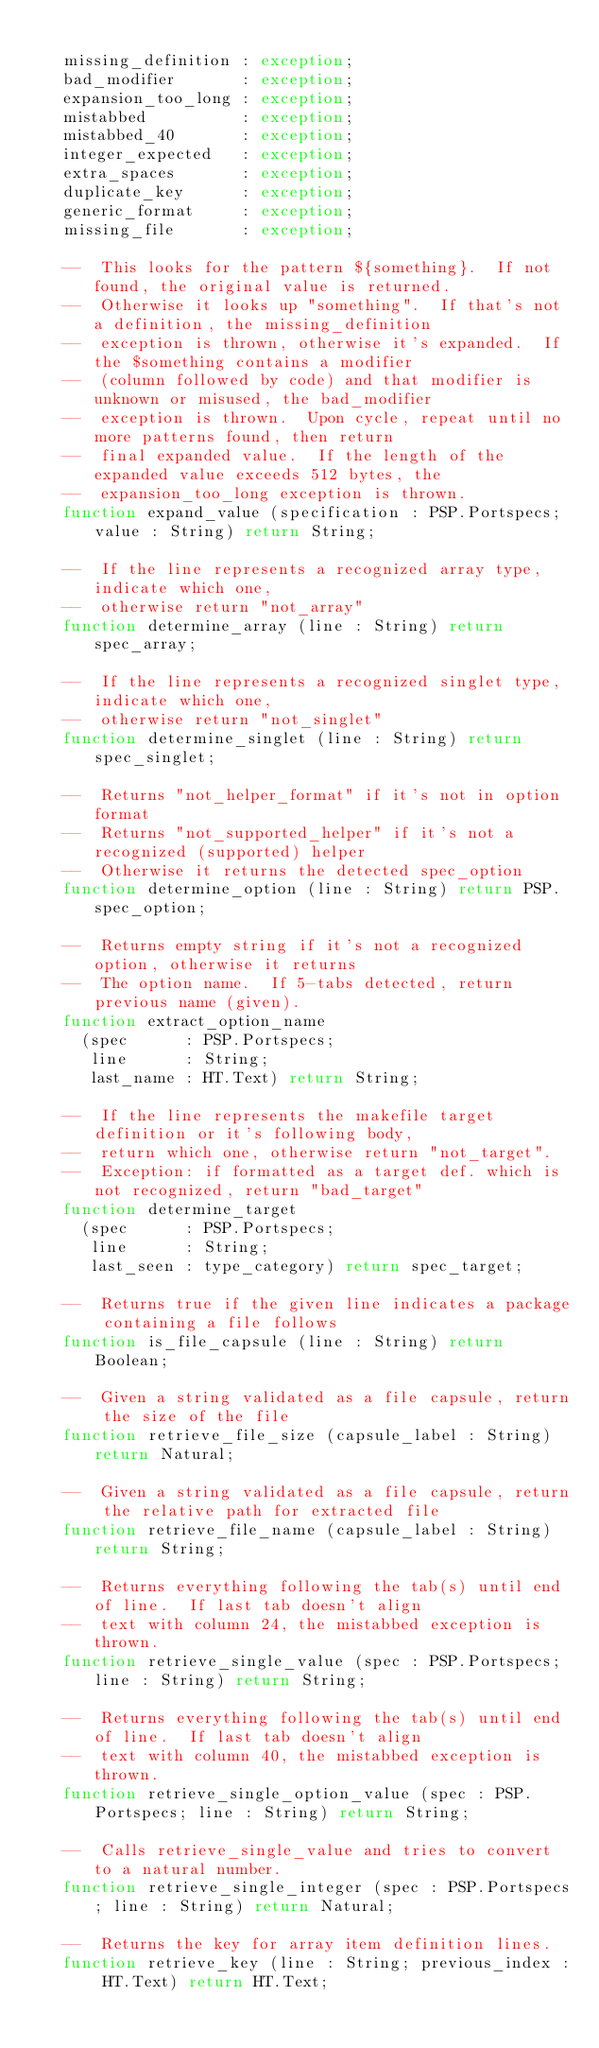Convert code to text. <code><loc_0><loc_0><loc_500><loc_500><_Ada_>
   missing_definition : exception;
   bad_modifier       : exception;
   expansion_too_long : exception;
   mistabbed          : exception;
   mistabbed_40       : exception;
   integer_expected   : exception;
   extra_spaces       : exception;
   duplicate_key      : exception;
   generic_format     : exception;
   missing_file       : exception;

   --  This looks for the pattern ${something}.  If not found, the original value is returned.
   --  Otherwise it looks up "something".  If that's not a definition, the missing_definition
   --  exception is thrown, otherwise it's expanded.  If the $something contains a modifier
   --  (column followed by code) and that modifier is unknown or misused, the bad_modifier
   --  exception is thrown.  Upon cycle, repeat until no more patterns found, then return
   --  final expanded value.  If the length of the expanded value exceeds 512 bytes, the
   --  expansion_too_long exception is thrown.
   function expand_value (specification : PSP.Portspecs; value : String) return String;

   --  If the line represents a recognized array type, indicate which one,
   --  otherwise return "not_array"
   function determine_array (line : String) return spec_array;

   --  If the line represents a recognized singlet type, indicate which one,
   --  otherwise return "not_singlet"
   function determine_singlet (line : String) return spec_singlet;

   --  Returns "not_helper_format" if it's not in option format
   --  Returns "not_supported_helper" if it's not a recognized (supported) helper
   --  Otherwise it returns the detected spec_option
   function determine_option (line : String) return PSP.spec_option;

   --  Returns empty string if it's not a recognized option, otherwise it returns
   --  The option name.  If 5-tabs detected, return previous name (given).
   function extract_option_name
     (spec      : PSP.Portspecs;
      line      : String;
      last_name : HT.Text) return String;

   --  If the line represents the makefile target definition or it's following body,
   --  return which one, otherwise return "not_target".
   --  Exception: if formatted as a target def. which is not recognized, return "bad_target"
   function determine_target
     (spec      : PSP.Portspecs;
      line      : String;
      last_seen : type_category) return spec_target;

   --  Returns true if the given line indicates a package containing a file follows
   function is_file_capsule (line : String) return Boolean;

   --  Given a string validated as a file capsule, return the size of the file
   function retrieve_file_size (capsule_label : String) return Natural;

   --  Given a string validated as a file capsule, return the relative path for extracted file
   function retrieve_file_name (capsule_label : String) return String;

   --  Returns everything following the tab(s) until end of line.  If last tab doesn't align
   --  text with column 24, the mistabbed exception is thrown.
   function retrieve_single_value (spec : PSP.Portspecs; line : String) return String;

   --  Returns everything following the tab(s) until end of line.  If last tab doesn't align
   --  text with column 40, the mistabbed exception is thrown.
   function retrieve_single_option_value (spec : PSP.Portspecs; line : String) return String;

   --  Calls retrieve_single_value and tries to convert to a natural number.
   function retrieve_single_integer (spec : PSP.Portspecs; line : String) return Natural;

   --  Returns the key for array item definition lines.
   function retrieve_key (line : String; previous_index : HT.Text) return HT.Text;
</code> 